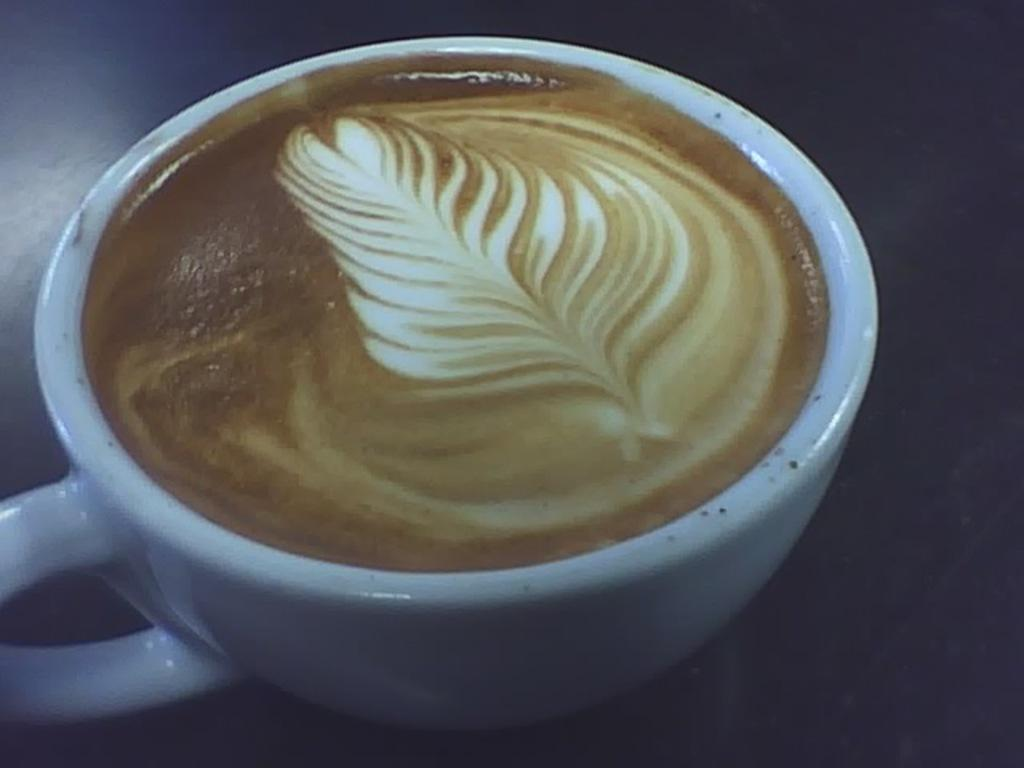What is in the cup that is visible in the image? There is a cup of coffee in the image. How many bananas are sitting on the edge of the cup in the image? There are no bananas present in the image; it only features a cup of coffee. 